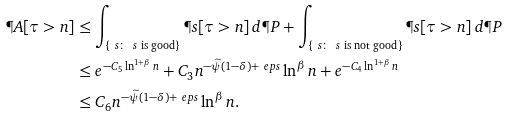<formula> <loc_0><loc_0><loc_500><loc_500>\P A [ \tau > n ] & \leq \int _ { \{ \ s \colon \, \ s \text { is good} \} } \P s [ \tau > n ] \, d \P P + \int _ { \{ \ s \colon \, \ s \text { is not good} \} } \P s [ \tau > n ] \, d \P P \\ & \leq e ^ { - C _ { 5 } \ln ^ { 1 + \beta } n } + C _ { 3 } n ^ { - \widetilde { \psi } ( 1 - \delta ) + \ e p s } \ln ^ { \beta } n + e ^ { - C _ { 4 } \ln ^ { 1 + \beta } n } \\ & \leq C _ { 6 } n ^ { - \widetilde { \psi } ( 1 - \delta ) + \ e p s } \ln ^ { \beta } n .</formula> 